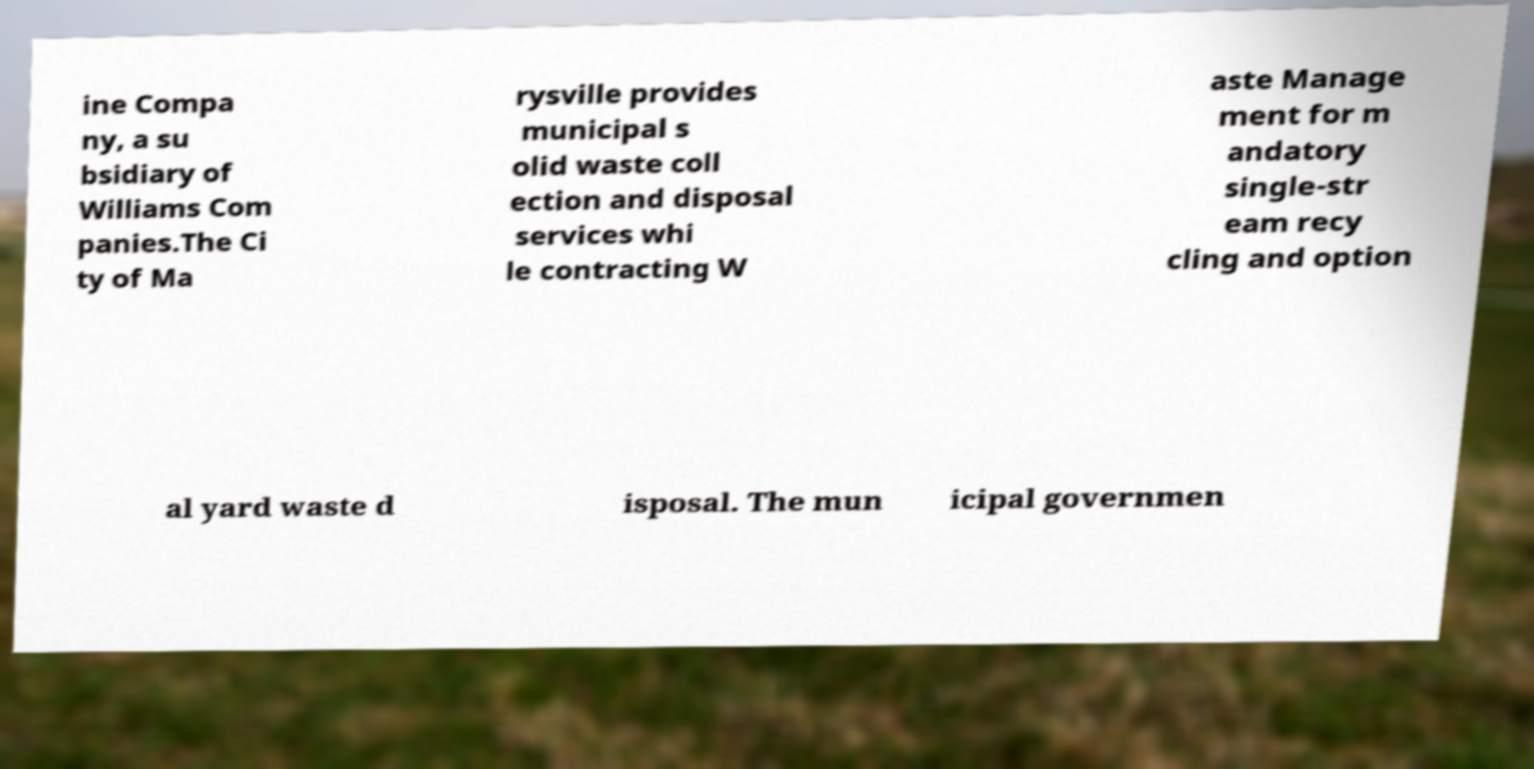Can you accurately transcribe the text from the provided image for me? ine Compa ny, a su bsidiary of Williams Com panies.The Ci ty of Ma rysville provides municipal s olid waste coll ection and disposal services whi le contracting W aste Manage ment for m andatory single-str eam recy cling and option al yard waste d isposal. The mun icipal governmen 